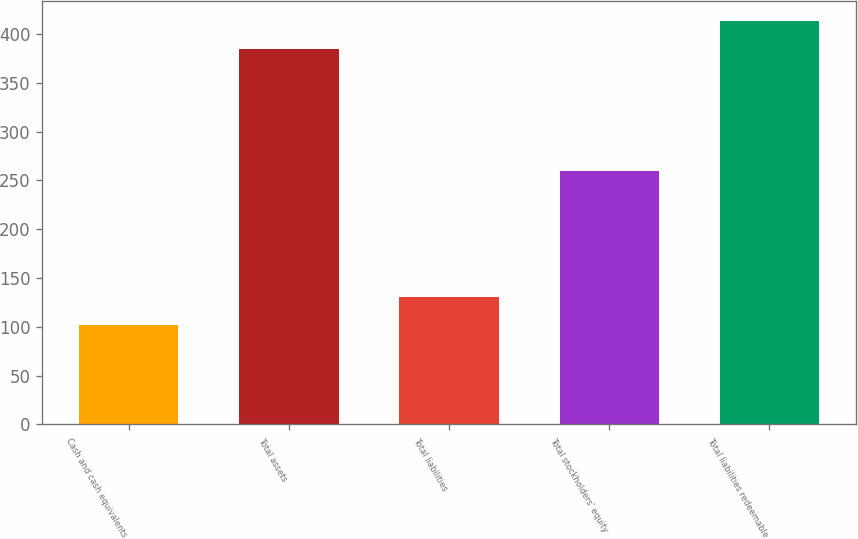<chart> <loc_0><loc_0><loc_500><loc_500><bar_chart><fcel>Cash and cash equivalents<fcel>Total assets<fcel>Total liabilities<fcel>Total stockholders' equity<fcel>Total liabilities redeemable<nl><fcel>102.3<fcel>384.8<fcel>130.55<fcel>259.6<fcel>413.05<nl></chart> 